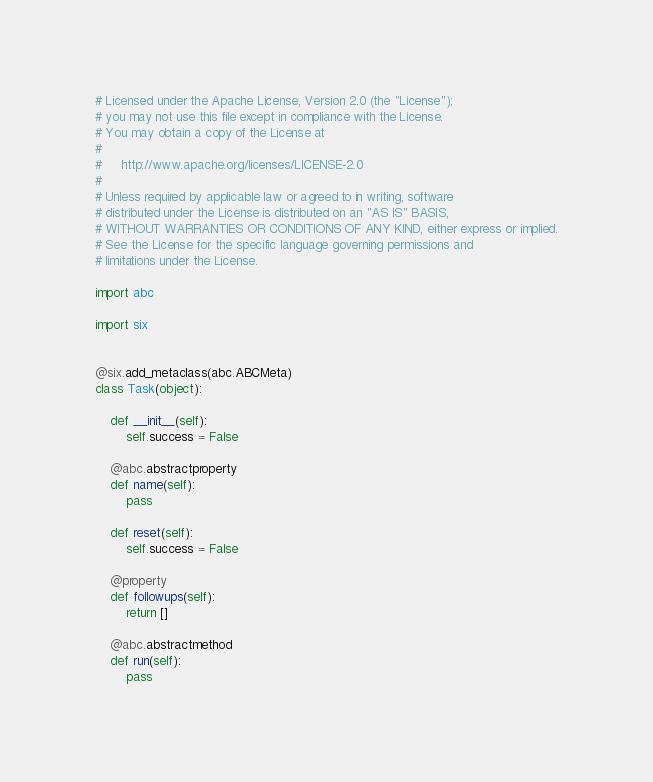<code> <loc_0><loc_0><loc_500><loc_500><_Python_># Licensed under the Apache License, Version 2.0 (the "License");
# you may not use this file except in compliance with the License.
# You may obtain a copy of the License at
#
#     http://www.apache.org/licenses/LICENSE-2.0
#
# Unless required by applicable law or agreed to in writing, software
# distributed under the License is distributed on an "AS IS" BASIS,
# WITHOUT WARRANTIES OR CONDITIONS OF ANY KIND, either express or implied.
# See the License for the specific language governing permissions and
# limitations under the License.

import abc

import six


@six.add_metaclass(abc.ABCMeta)
class Task(object):

    def __init__(self):
        self.success = False

    @abc.abstractproperty
    def name(self):
        pass

    def reset(self):
        self.success = False

    @property
    def followups(self):
        return []

    @abc.abstractmethod
    def run(self):
        pass
</code> 